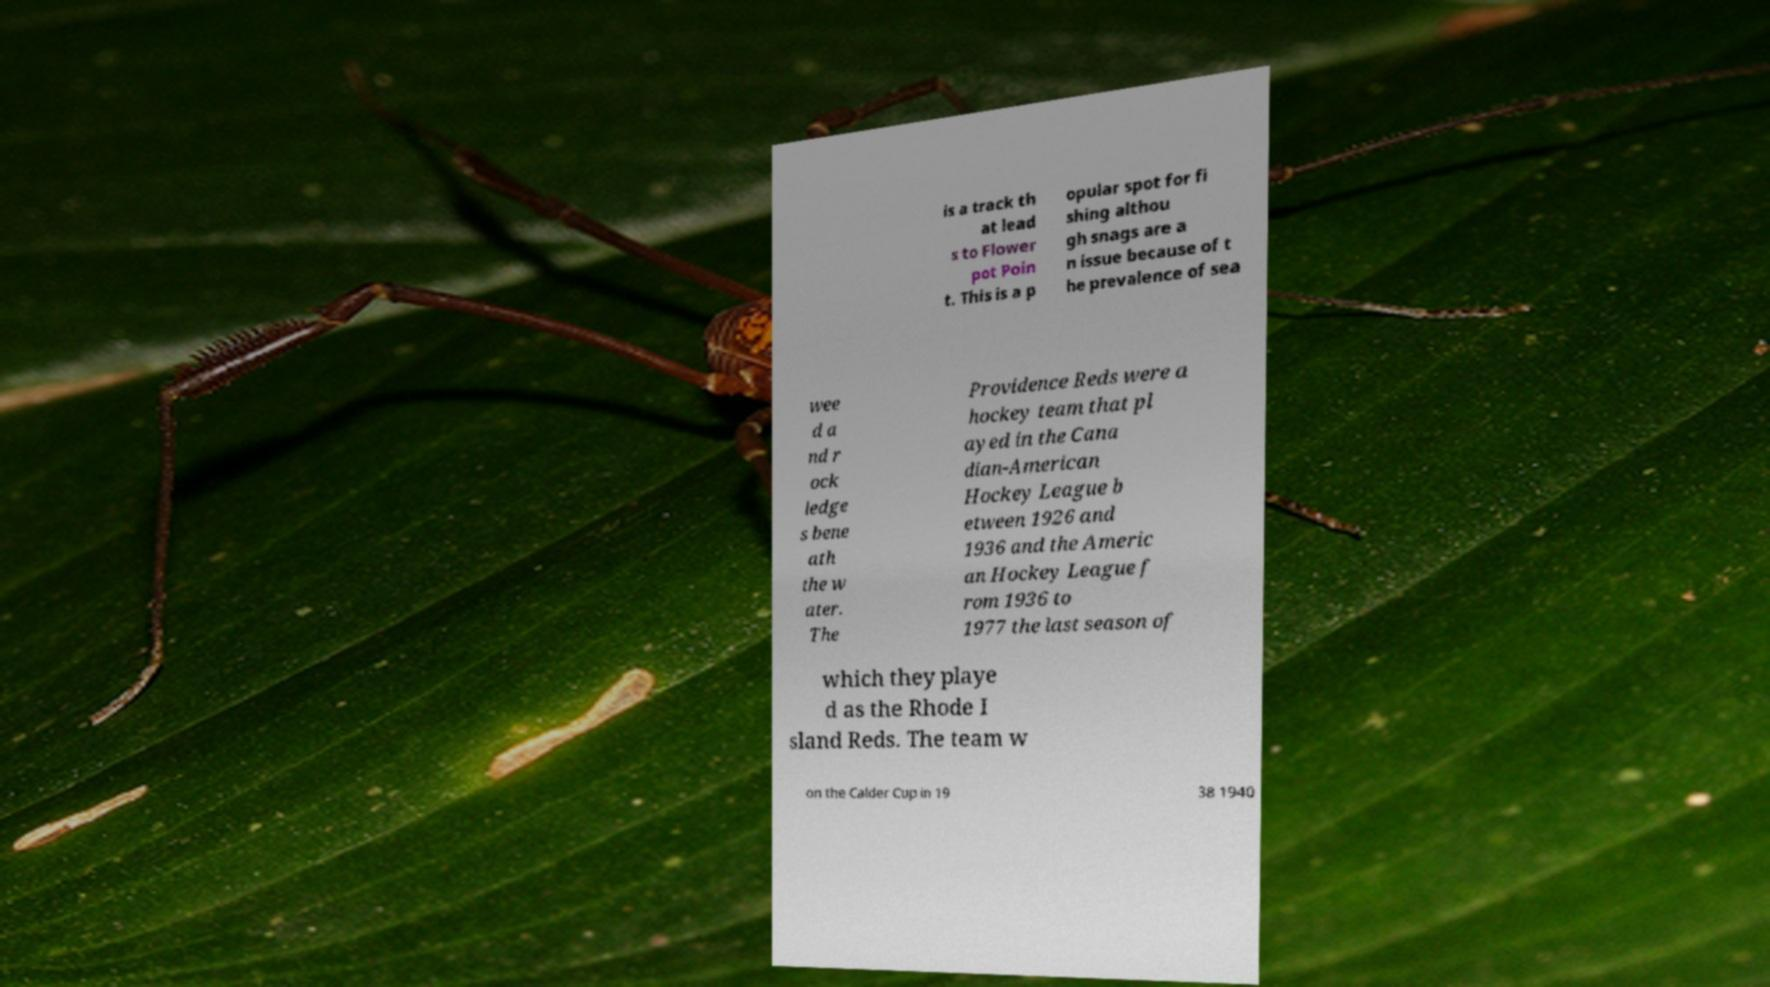I need the written content from this picture converted into text. Can you do that? is a track th at lead s to Flower pot Poin t. This is a p opular spot for fi shing althou gh snags are a n issue because of t he prevalence of sea wee d a nd r ock ledge s bene ath the w ater. The Providence Reds were a hockey team that pl ayed in the Cana dian-American Hockey League b etween 1926 and 1936 and the Americ an Hockey League f rom 1936 to 1977 the last season of which they playe d as the Rhode I sland Reds. The team w on the Calder Cup in 19 38 1940 